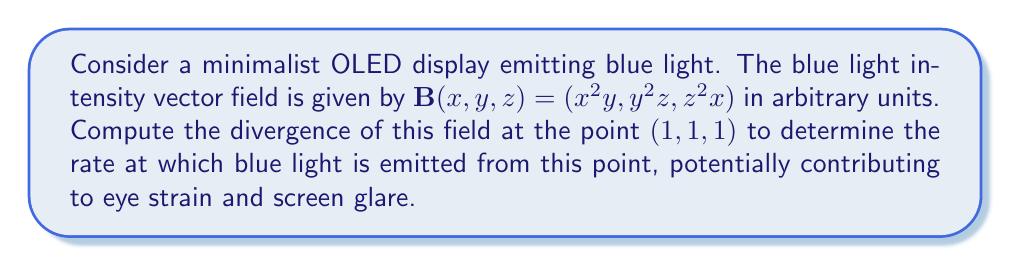Can you answer this question? To solve this problem, we need to follow these steps:

1) The divergence of a vector field $\mathbf{F}(x,y,z) = (F_1, F_2, F_3)$ is given by:

   $$\text{div}\mathbf{F} = \nabla \cdot \mathbf{F} = \frac{\partial F_1}{\partial x} + \frac{\partial F_2}{\partial y} + \frac{\partial F_3}{\partial z}$$

2) In our case, $\mathbf{B}(x,y,z) = (x^2y, y^2z, z^2x)$, so:
   
   $F_1 = x^2y$
   $F_2 = y^2z$
   $F_3 = z^2x$

3) Let's compute each partial derivative:

   $\frac{\partial F_1}{\partial x} = \frac{\partial}{\partial x}(x^2y) = 2xy$
   
   $\frac{\partial F_2}{\partial y} = \frac{\partial}{\partial y}(y^2z) = 2yz$
   
   $\frac{\partial F_3}{\partial z} = \frac{\partial}{\partial z}(z^2x) = 2zx$

4) Now, we can sum these partial derivatives:

   $$\text{div}\mathbf{B} = 2xy + 2yz + 2zx$$

5) We need to evaluate this at the point $(1,1,1)$:

   $$\text{div}\mathbf{B}(1,1,1) = 2(1)(1) + 2(1)(1) + 2(1)(1) = 2 + 2 + 2 = 6$$

The positive divergence indicates that this point is a source of blue light emission, which could contribute to eye strain and screen glare.
Answer: $6$ (arbitrary units) 